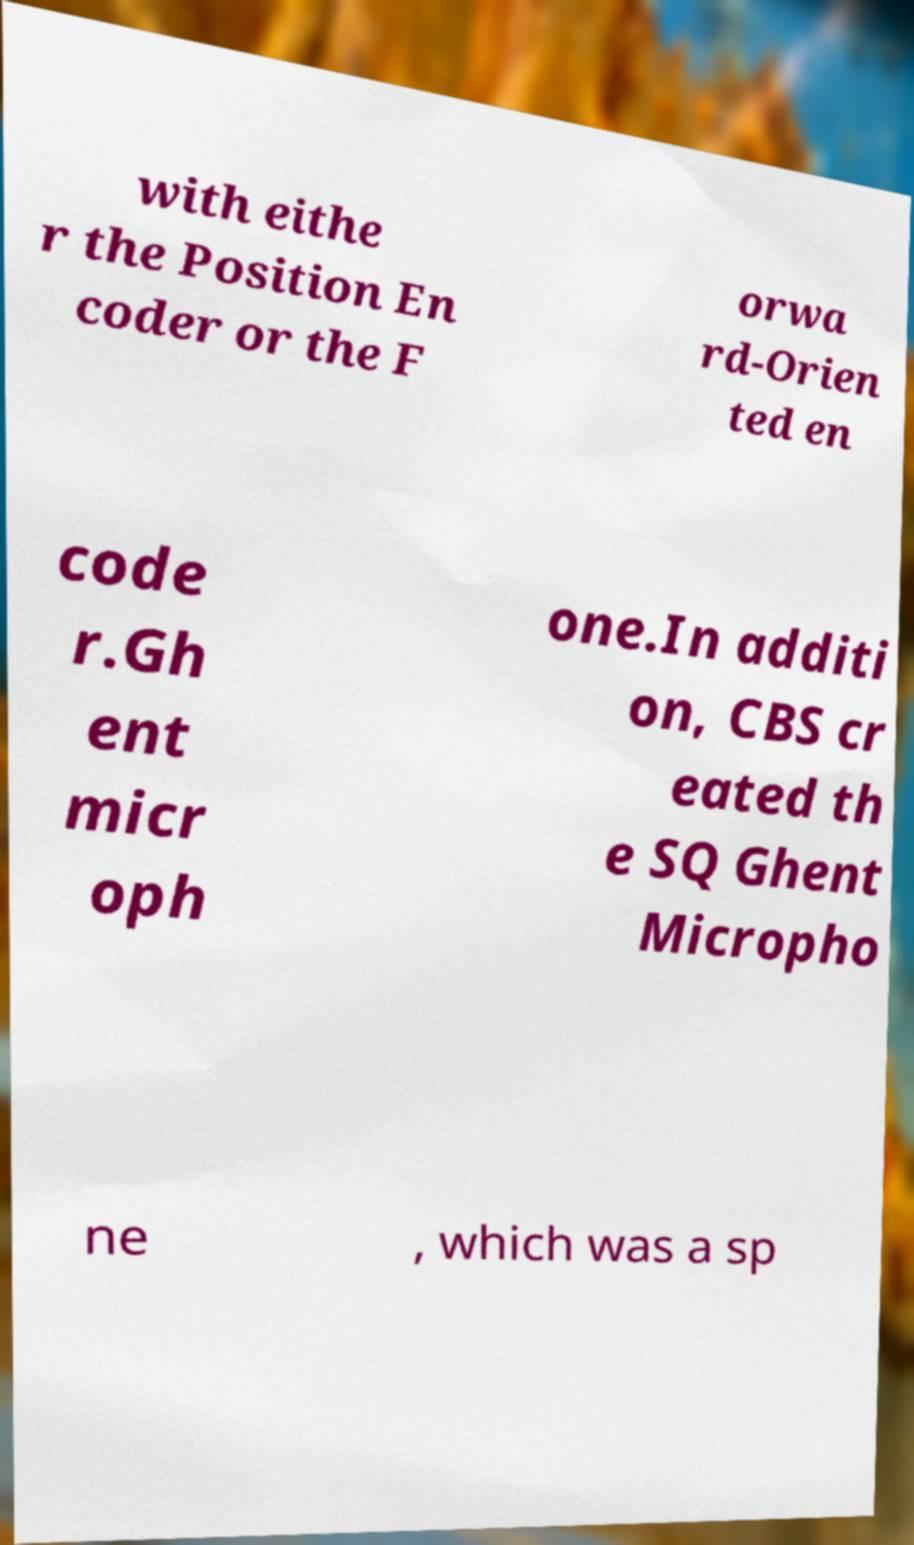Please identify and transcribe the text found in this image. with eithe r the Position En coder or the F orwa rd-Orien ted en code r.Gh ent micr oph one.In additi on, CBS cr eated th e SQ Ghent Micropho ne , which was a sp 